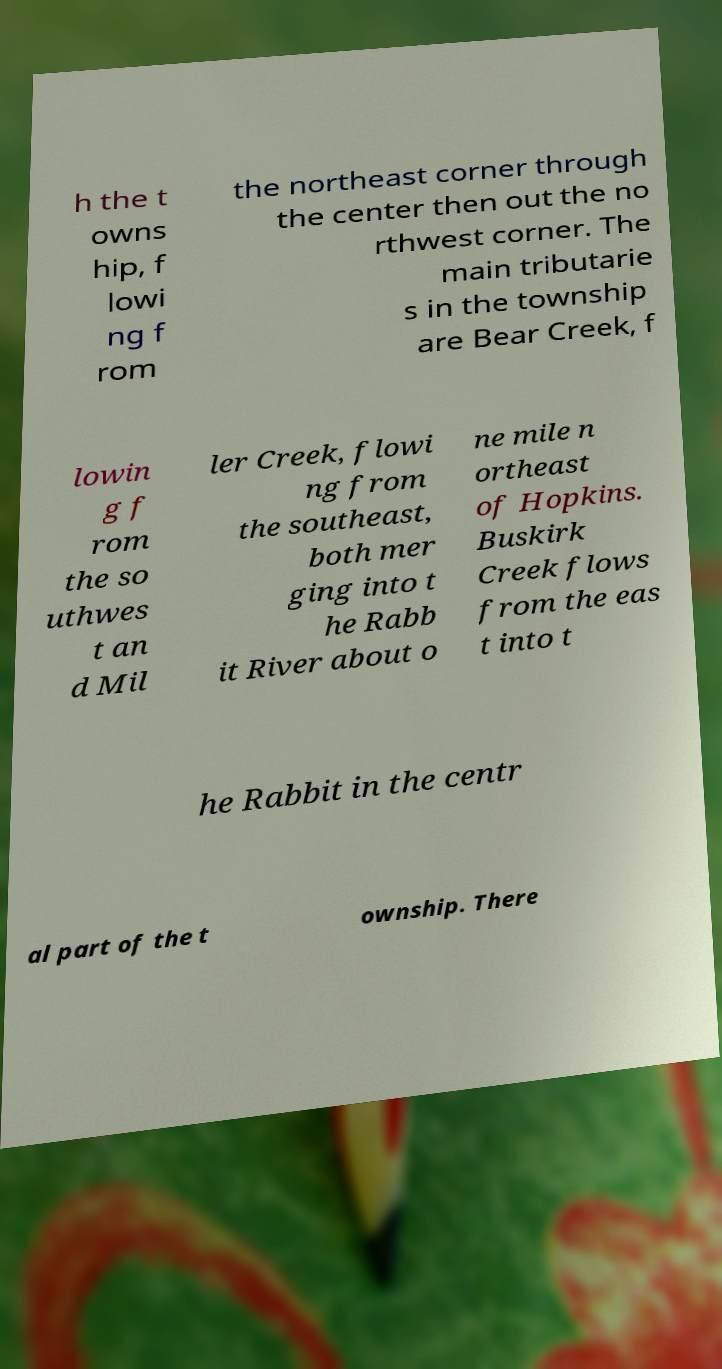Could you extract and type out the text from this image? h the t owns hip, f lowi ng f rom the northeast corner through the center then out the no rthwest corner. The main tributarie s in the township are Bear Creek, f lowin g f rom the so uthwes t an d Mil ler Creek, flowi ng from the southeast, both mer ging into t he Rabb it River about o ne mile n ortheast of Hopkins. Buskirk Creek flows from the eas t into t he Rabbit in the centr al part of the t ownship. There 